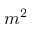<formula> <loc_0><loc_0><loc_500><loc_500>m ^ { 2 }</formula> 